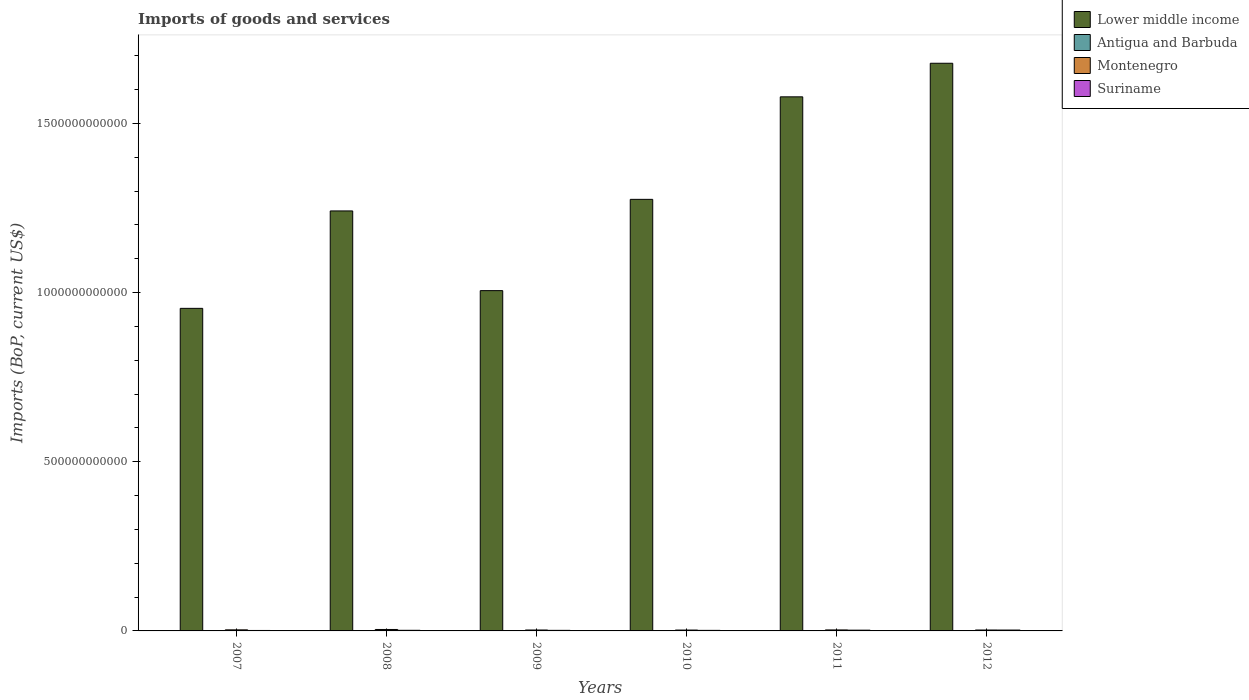How many different coloured bars are there?
Keep it short and to the point. 4. How many groups of bars are there?
Give a very brief answer. 6. Are the number of bars per tick equal to the number of legend labels?
Your answer should be compact. Yes. Are the number of bars on each tick of the X-axis equal?
Your answer should be compact. Yes. What is the amount spent on imports in Lower middle income in 2011?
Ensure brevity in your answer.  1.58e+12. Across all years, what is the maximum amount spent on imports in Lower middle income?
Ensure brevity in your answer.  1.68e+12. Across all years, what is the minimum amount spent on imports in Suriname?
Give a very brief answer. 1.36e+09. In which year was the amount spent on imports in Montenegro minimum?
Your answer should be compact. 2010. What is the total amount spent on imports in Antigua and Barbuda in the graph?
Your response must be concise. 4.60e+09. What is the difference between the amount spent on imports in Suriname in 2009 and that in 2010?
Give a very brief answer. 1.91e+07. What is the difference between the amount spent on imports in Antigua and Barbuda in 2008 and the amount spent on imports in Suriname in 2011?
Your answer should be very brief. -1.29e+09. What is the average amount spent on imports in Suriname per year?
Ensure brevity in your answer.  1.89e+09. In the year 2012, what is the difference between the amount spent on imports in Montenegro and amount spent on imports in Antigua and Barbuda?
Offer a very short reply. 2.04e+09. In how many years, is the amount spent on imports in Suriname greater than 100000000000 US$?
Provide a short and direct response. 0. What is the ratio of the amount spent on imports in Antigua and Barbuda in 2007 to that in 2008?
Your answer should be compact. 0.98. Is the difference between the amount spent on imports in Montenegro in 2007 and 2011 greater than the difference between the amount spent on imports in Antigua and Barbuda in 2007 and 2011?
Your response must be concise. No. What is the difference between the highest and the second highest amount spent on imports in Antigua and Barbuda?
Keep it short and to the point. 1.98e+07. What is the difference between the highest and the lowest amount spent on imports in Suriname?
Your response must be concise. 1.22e+09. In how many years, is the amount spent on imports in Lower middle income greater than the average amount spent on imports in Lower middle income taken over all years?
Keep it short and to the point. 2. Is it the case that in every year, the sum of the amount spent on imports in Suriname and amount spent on imports in Montenegro is greater than the sum of amount spent on imports in Lower middle income and amount spent on imports in Antigua and Barbuda?
Your answer should be very brief. Yes. What does the 1st bar from the left in 2008 represents?
Provide a short and direct response. Lower middle income. What does the 2nd bar from the right in 2008 represents?
Your response must be concise. Montenegro. How many bars are there?
Give a very brief answer. 24. How many years are there in the graph?
Make the answer very short. 6. What is the difference between two consecutive major ticks on the Y-axis?
Offer a terse response. 5.00e+11. Are the values on the major ticks of Y-axis written in scientific E-notation?
Keep it short and to the point. No. Does the graph contain any zero values?
Your response must be concise. No. Where does the legend appear in the graph?
Provide a succinct answer. Top right. What is the title of the graph?
Your answer should be very brief. Imports of goods and services. Does "Lebanon" appear as one of the legend labels in the graph?
Give a very brief answer. No. What is the label or title of the X-axis?
Offer a terse response. Years. What is the label or title of the Y-axis?
Your answer should be compact. Imports (BoP, current US$). What is the Imports (BoP, current US$) in Lower middle income in 2007?
Your answer should be compact. 9.53e+11. What is the Imports (BoP, current US$) in Antigua and Barbuda in 2007?
Offer a terse response. 9.32e+08. What is the Imports (BoP, current US$) of Montenegro in 2007?
Your response must be concise. 3.17e+09. What is the Imports (BoP, current US$) in Suriname in 2007?
Give a very brief answer. 1.36e+09. What is the Imports (BoP, current US$) in Lower middle income in 2008?
Provide a succinct answer. 1.24e+12. What is the Imports (BoP, current US$) of Antigua and Barbuda in 2008?
Your answer should be compact. 9.52e+08. What is the Imports (BoP, current US$) of Montenegro in 2008?
Provide a succinct answer. 4.25e+09. What is the Imports (BoP, current US$) of Suriname in 2008?
Your answer should be compact. 1.81e+09. What is the Imports (BoP, current US$) in Lower middle income in 2009?
Offer a terse response. 1.01e+12. What is the Imports (BoP, current US$) of Antigua and Barbuda in 2009?
Offer a terse response. 7.06e+08. What is the Imports (BoP, current US$) of Montenegro in 2009?
Give a very brief answer. 2.71e+09. What is the Imports (BoP, current US$) in Suriname in 2009?
Offer a very short reply. 1.68e+09. What is the Imports (BoP, current US$) in Lower middle income in 2010?
Your answer should be compact. 1.28e+12. What is the Imports (BoP, current US$) in Antigua and Barbuda in 2010?
Offer a very short reply. 6.79e+08. What is the Imports (BoP, current US$) in Montenegro in 2010?
Keep it short and to the point. 2.58e+09. What is the Imports (BoP, current US$) in Suriname in 2010?
Make the answer very short. 1.66e+09. What is the Imports (BoP, current US$) of Lower middle income in 2011?
Ensure brevity in your answer.  1.58e+12. What is the Imports (BoP, current US$) in Antigua and Barbuda in 2011?
Provide a succinct answer. 6.42e+08. What is the Imports (BoP, current US$) of Montenegro in 2011?
Make the answer very short. 2.92e+09. What is the Imports (BoP, current US$) of Suriname in 2011?
Your answer should be compact. 2.24e+09. What is the Imports (BoP, current US$) in Lower middle income in 2012?
Give a very brief answer. 1.68e+12. What is the Imports (BoP, current US$) in Antigua and Barbuda in 2012?
Your response must be concise. 6.88e+08. What is the Imports (BoP, current US$) of Montenegro in 2012?
Your response must be concise. 2.72e+09. What is the Imports (BoP, current US$) of Suriname in 2012?
Keep it short and to the point. 2.58e+09. Across all years, what is the maximum Imports (BoP, current US$) in Lower middle income?
Ensure brevity in your answer.  1.68e+12. Across all years, what is the maximum Imports (BoP, current US$) in Antigua and Barbuda?
Make the answer very short. 9.52e+08. Across all years, what is the maximum Imports (BoP, current US$) of Montenegro?
Ensure brevity in your answer.  4.25e+09. Across all years, what is the maximum Imports (BoP, current US$) of Suriname?
Your answer should be compact. 2.58e+09. Across all years, what is the minimum Imports (BoP, current US$) of Lower middle income?
Provide a short and direct response. 9.53e+11. Across all years, what is the minimum Imports (BoP, current US$) of Antigua and Barbuda?
Your response must be concise. 6.42e+08. Across all years, what is the minimum Imports (BoP, current US$) of Montenegro?
Ensure brevity in your answer.  2.58e+09. Across all years, what is the minimum Imports (BoP, current US$) of Suriname?
Provide a short and direct response. 1.36e+09. What is the total Imports (BoP, current US$) of Lower middle income in the graph?
Your answer should be compact. 7.73e+12. What is the total Imports (BoP, current US$) of Antigua and Barbuda in the graph?
Provide a succinct answer. 4.60e+09. What is the total Imports (BoP, current US$) in Montenegro in the graph?
Make the answer very short. 1.84e+1. What is the total Imports (BoP, current US$) of Suriname in the graph?
Make the answer very short. 1.13e+1. What is the difference between the Imports (BoP, current US$) in Lower middle income in 2007 and that in 2008?
Offer a very short reply. -2.88e+11. What is the difference between the Imports (BoP, current US$) of Antigua and Barbuda in 2007 and that in 2008?
Offer a terse response. -1.98e+07. What is the difference between the Imports (BoP, current US$) of Montenegro in 2007 and that in 2008?
Keep it short and to the point. -1.08e+09. What is the difference between the Imports (BoP, current US$) of Suriname in 2007 and that in 2008?
Your answer should be very brief. -4.51e+08. What is the difference between the Imports (BoP, current US$) in Lower middle income in 2007 and that in 2009?
Your answer should be compact. -5.24e+1. What is the difference between the Imports (BoP, current US$) of Antigua and Barbuda in 2007 and that in 2009?
Ensure brevity in your answer.  2.26e+08. What is the difference between the Imports (BoP, current US$) of Montenegro in 2007 and that in 2009?
Provide a succinct answer. 4.57e+08. What is the difference between the Imports (BoP, current US$) of Suriname in 2007 and that in 2009?
Provide a succinct answer. -3.13e+08. What is the difference between the Imports (BoP, current US$) in Lower middle income in 2007 and that in 2010?
Offer a terse response. -3.22e+11. What is the difference between the Imports (BoP, current US$) of Antigua and Barbuda in 2007 and that in 2010?
Your answer should be very brief. 2.53e+08. What is the difference between the Imports (BoP, current US$) in Montenegro in 2007 and that in 2010?
Provide a short and direct response. 5.92e+08. What is the difference between the Imports (BoP, current US$) in Suriname in 2007 and that in 2010?
Give a very brief answer. -2.94e+08. What is the difference between the Imports (BoP, current US$) in Lower middle income in 2007 and that in 2011?
Offer a terse response. -6.25e+11. What is the difference between the Imports (BoP, current US$) in Antigua and Barbuda in 2007 and that in 2011?
Offer a very short reply. 2.91e+08. What is the difference between the Imports (BoP, current US$) in Montenegro in 2007 and that in 2011?
Your response must be concise. 2.51e+08. What is the difference between the Imports (BoP, current US$) of Suriname in 2007 and that in 2011?
Your answer should be compact. -8.79e+08. What is the difference between the Imports (BoP, current US$) in Lower middle income in 2007 and that in 2012?
Your answer should be very brief. -7.24e+11. What is the difference between the Imports (BoP, current US$) of Antigua and Barbuda in 2007 and that in 2012?
Your answer should be very brief. 2.45e+08. What is the difference between the Imports (BoP, current US$) of Montenegro in 2007 and that in 2012?
Offer a terse response. 4.48e+08. What is the difference between the Imports (BoP, current US$) in Suriname in 2007 and that in 2012?
Your answer should be compact. -1.22e+09. What is the difference between the Imports (BoP, current US$) in Lower middle income in 2008 and that in 2009?
Offer a very short reply. 2.36e+11. What is the difference between the Imports (BoP, current US$) in Antigua and Barbuda in 2008 and that in 2009?
Keep it short and to the point. 2.46e+08. What is the difference between the Imports (BoP, current US$) of Montenegro in 2008 and that in 2009?
Your answer should be very brief. 1.53e+09. What is the difference between the Imports (BoP, current US$) in Suriname in 2008 and that in 2009?
Give a very brief answer. 1.38e+08. What is the difference between the Imports (BoP, current US$) in Lower middle income in 2008 and that in 2010?
Offer a terse response. -3.43e+1. What is the difference between the Imports (BoP, current US$) in Antigua and Barbuda in 2008 and that in 2010?
Your answer should be compact. 2.73e+08. What is the difference between the Imports (BoP, current US$) of Montenegro in 2008 and that in 2010?
Make the answer very short. 1.67e+09. What is the difference between the Imports (BoP, current US$) of Suriname in 2008 and that in 2010?
Your response must be concise. 1.57e+08. What is the difference between the Imports (BoP, current US$) in Lower middle income in 2008 and that in 2011?
Give a very brief answer. -3.37e+11. What is the difference between the Imports (BoP, current US$) in Antigua and Barbuda in 2008 and that in 2011?
Your response must be concise. 3.11e+08. What is the difference between the Imports (BoP, current US$) of Montenegro in 2008 and that in 2011?
Provide a succinct answer. 1.33e+09. What is the difference between the Imports (BoP, current US$) in Suriname in 2008 and that in 2011?
Provide a short and direct response. -4.28e+08. What is the difference between the Imports (BoP, current US$) of Lower middle income in 2008 and that in 2012?
Your answer should be very brief. -4.36e+11. What is the difference between the Imports (BoP, current US$) in Antigua and Barbuda in 2008 and that in 2012?
Your answer should be very brief. 2.65e+08. What is the difference between the Imports (BoP, current US$) in Montenegro in 2008 and that in 2012?
Your answer should be very brief. 1.53e+09. What is the difference between the Imports (BoP, current US$) in Suriname in 2008 and that in 2012?
Offer a very short reply. -7.70e+08. What is the difference between the Imports (BoP, current US$) of Lower middle income in 2009 and that in 2010?
Provide a short and direct response. -2.70e+11. What is the difference between the Imports (BoP, current US$) of Antigua and Barbuda in 2009 and that in 2010?
Your answer should be very brief. 2.75e+07. What is the difference between the Imports (BoP, current US$) of Montenegro in 2009 and that in 2010?
Offer a terse response. 1.34e+08. What is the difference between the Imports (BoP, current US$) of Suriname in 2009 and that in 2010?
Provide a succinct answer. 1.91e+07. What is the difference between the Imports (BoP, current US$) of Lower middle income in 2009 and that in 2011?
Ensure brevity in your answer.  -5.73e+11. What is the difference between the Imports (BoP, current US$) of Antigua and Barbuda in 2009 and that in 2011?
Provide a short and direct response. 6.48e+07. What is the difference between the Imports (BoP, current US$) in Montenegro in 2009 and that in 2011?
Make the answer very short. -2.06e+08. What is the difference between the Imports (BoP, current US$) of Suriname in 2009 and that in 2011?
Give a very brief answer. -5.66e+08. What is the difference between the Imports (BoP, current US$) of Lower middle income in 2009 and that in 2012?
Your response must be concise. -6.72e+11. What is the difference between the Imports (BoP, current US$) in Antigua and Barbuda in 2009 and that in 2012?
Give a very brief answer. 1.88e+07. What is the difference between the Imports (BoP, current US$) in Montenegro in 2009 and that in 2012?
Provide a short and direct response. -9.23e+06. What is the difference between the Imports (BoP, current US$) of Suriname in 2009 and that in 2012?
Make the answer very short. -9.08e+08. What is the difference between the Imports (BoP, current US$) of Lower middle income in 2010 and that in 2011?
Ensure brevity in your answer.  -3.03e+11. What is the difference between the Imports (BoP, current US$) in Antigua and Barbuda in 2010 and that in 2011?
Keep it short and to the point. 3.73e+07. What is the difference between the Imports (BoP, current US$) in Montenegro in 2010 and that in 2011?
Provide a short and direct response. -3.40e+08. What is the difference between the Imports (BoP, current US$) in Suriname in 2010 and that in 2011?
Your answer should be compact. -5.85e+08. What is the difference between the Imports (BoP, current US$) of Lower middle income in 2010 and that in 2012?
Offer a terse response. -4.02e+11. What is the difference between the Imports (BoP, current US$) of Antigua and Barbuda in 2010 and that in 2012?
Keep it short and to the point. -8.70e+06. What is the difference between the Imports (BoP, current US$) in Montenegro in 2010 and that in 2012?
Your answer should be very brief. -1.44e+08. What is the difference between the Imports (BoP, current US$) in Suriname in 2010 and that in 2012?
Keep it short and to the point. -9.27e+08. What is the difference between the Imports (BoP, current US$) in Lower middle income in 2011 and that in 2012?
Your answer should be very brief. -9.92e+1. What is the difference between the Imports (BoP, current US$) in Antigua and Barbuda in 2011 and that in 2012?
Keep it short and to the point. -4.60e+07. What is the difference between the Imports (BoP, current US$) in Montenegro in 2011 and that in 2012?
Offer a very short reply. 1.96e+08. What is the difference between the Imports (BoP, current US$) of Suriname in 2011 and that in 2012?
Make the answer very short. -3.42e+08. What is the difference between the Imports (BoP, current US$) in Lower middle income in 2007 and the Imports (BoP, current US$) in Antigua and Barbuda in 2008?
Offer a very short reply. 9.52e+11. What is the difference between the Imports (BoP, current US$) of Lower middle income in 2007 and the Imports (BoP, current US$) of Montenegro in 2008?
Provide a succinct answer. 9.49e+11. What is the difference between the Imports (BoP, current US$) of Lower middle income in 2007 and the Imports (BoP, current US$) of Suriname in 2008?
Offer a terse response. 9.52e+11. What is the difference between the Imports (BoP, current US$) in Antigua and Barbuda in 2007 and the Imports (BoP, current US$) in Montenegro in 2008?
Provide a succinct answer. -3.32e+09. What is the difference between the Imports (BoP, current US$) in Antigua and Barbuda in 2007 and the Imports (BoP, current US$) in Suriname in 2008?
Your answer should be very brief. -8.82e+08. What is the difference between the Imports (BoP, current US$) in Montenegro in 2007 and the Imports (BoP, current US$) in Suriname in 2008?
Ensure brevity in your answer.  1.36e+09. What is the difference between the Imports (BoP, current US$) of Lower middle income in 2007 and the Imports (BoP, current US$) of Antigua and Barbuda in 2009?
Give a very brief answer. 9.53e+11. What is the difference between the Imports (BoP, current US$) of Lower middle income in 2007 and the Imports (BoP, current US$) of Montenegro in 2009?
Provide a succinct answer. 9.51e+11. What is the difference between the Imports (BoP, current US$) in Lower middle income in 2007 and the Imports (BoP, current US$) in Suriname in 2009?
Your response must be concise. 9.52e+11. What is the difference between the Imports (BoP, current US$) of Antigua and Barbuda in 2007 and the Imports (BoP, current US$) of Montenegro in 2009?
Ensure brevity in your answer.  -1.78e+09. What is the difference between the Imports (BoP, current US$) of Antigua and Barbuda in 2007 and the Imports (BoP, current US$) of Suriname in 2009?
Your answer should be very brief. -7.44e+08. What is the difference between the Imports (BoP, current US$) of Montenegro in 2007 and the Imports (BoP, current US$) of Suriname in 2009?
Provide a succinct answer. 1.49e+09. What is the difference between the Imports (BoP, current US$) in Lower middle income in 2007 and the Imports (BoP, current US$) in Antigua and Barbuda in 2010?
Offer a very short reply. 9.53e+11. What is the difference between the Imports (BoP, current US$) in Lower middle income in 2007 and the Imports (BoP, current US$) in Montenegro in 2010?
Give a very brief answer. 9.51e+11. What is the difference between the Imports (BoP, current US$) of Lower middle income in 2007 and the Imports (BoP, current US$) of Suriname in 2010?
Give a very brief answer. 9.52e+11. What is the difference between the Imports (BoP, current US$) of Antigua and Barbuda in 2007 and the Imports (BoP, current US$) of Montenegro in 2010?
Your answer should be very brief. -1.65e+09. What is the difference between the Imports (BoP, current US$) of Antigua and Barbuda in 2007 and the Imports (BoP, current US$) of Suriname in 2010?
Offer a very short reply. -7.25e+08. What is the difference between the Imports (BoP, current US$) of Montenegro in 2007 and the Imports (BoP, current US$) of Suriname in 2010?
Provide a short and direct response. 1.51e+09. What is the difference between the Imports (BoP, current US$) of Lower middle income in 2007 and the Imports (BoP, current US$) of Antigua and Barbuda in 2011?
Your answer should be compact. 9.53e+11. What is the difference between the Imports (BoP, current US$) of Lower middle income in 2007 and the Imports (BoP, current US$) of Montenegro in 2011?
Provide a succinct answer. 9.51e+11. What is the difference between the Imports (BoP, current US$) of Lower middle income in 2007 and the Imports (BoP, current US$) of Suriname in 2011?
Your answer should be very brief. 9.51e+11. What is the difference between the Imports (BoP, current US$) in Antigua and Barbuda in 2007 and the Imports (BoP, current US$) in Montenegro in 2011?
Ensure brevity in your answer.  -1.99e+09. What is the difference between the Imports (BoP, current US$) in Antigua and Barbuda in 2007 and the Imports (BoP, current US$) in Suriname in 2011?
Offer a terse response. -1.31e+09. What is the difference between the Imports (BoP, current US$) of Montenegro in 2007 and the Imports (BoP, current US$) of Suriname in 2011?
Offer a very short reply. 9.29e+08. What is the difference between the Imports (BoP, current US$) in Lower middle income in 2007 and the Imports (BoP, current US$) in Antigua and Barbuda in 2012?
Your response must be concise. 9.53e+11. What is the difference between the Imports (BoP, current US$) of Lower middle income in 2007 and the Imports (BoP, current US$) of Montenegro in 2012?
Provide a succinct answer. 9.51e+11. What is the difference between the Imports (BoP, current US$) in Lower middle income in 2007 and the Imports (BoP, current US$) in Suriname in 2012?
Give a very brief answer. 9.51e+11. What is the difference between the Imports (BoP, current US$) in Antigua and Barbuda in 2007 and the Imports (BoP, current US$) in Montenegro in 2012?
Your answer should be compact. -1.79e+09. What is the difference between the Imports (BoP, current US$) of Antigua and Barbuda in 2007 and the Imports (BoP, current US$) of Suriname in 2012?
Provide a short and direct response. -1.65e+09. What is the difference between the Imports (BoP, current US$) in Montenegro in 2007 and the Imports (BoP, current US$) in Suriname in 2012?
Provide a short and direct response. 5.87e+08. What is the difference between the Imports (BoP, current US$) in Lower middle income in 2008 and the Imports (BoP, current US$) in Antigua and Barbuda in 2009?
Provide a succinct answer. 1.24e+12. What is the difference between the Imports (BoP, current US$) of Lower middle income in 2008 and the Imports (BoP, current US$) of Montenegro in 2009?
Your response must be concise. 1.24e+12. What is the difference between the Imports (BoP, current US$) in Lower middle income in 2008 and the Imports (BoP, current US$) in Suriname in 2009?
Ensure brevity in your answer.  1.24e+12. What is the difference between the Imports (BoP, current US$) in Antigua and Barbuda in 2008 and the Imports (BoP, current US$) in Montenegro in 2009?
Ensure brevity in your answer.  -1.76e+09. What is the difference between the Imports (BoP, current US$) in Antigua and Barbuda in 2008 and the Imports (BoP, current US$) in Suriname in 2009?
Your answer should be compact. -7.24e+08. What is the difference between the Imports (BoP, current US$) of Montenegro in 2008 and the Imports (BoP, current US$) of Suriname in 2009?
Your answer should be compact. 2.57e+09. What is the difference between the Imports (BoP, current US$) of Lower middle income in 2008 and the Imports (BoP, current US$) of Antigua and Barbuda in 2010?
Keep it short and to the point. 1.24e+12. What is the difference between the Imports (BoP, current US$) of Lower middle income in 2008 and the Imports (BoP, current US$) of Montenegro in 2010?
Ensure brevity in your answer.  1.24e+12. What is the difference between the Imports (BoP, current US$) of Lower middle income in 2008 and the Imports (BoP, current US$) of Suriname in 2010?
Ensure brevity in your answer.  1.24e+12. What is the difference between the Imports (BoP, current US$) in Antigua and Barbuda in 2008 and the Imports (BoP, current US$) in Montenegro in 2010?
Your response must be concise. -1.63e+09. What is the difference between the Imports (BoP, current US$) of Antigua and Barbuda in 2008 and the Imports (BoP, current US$) of Suriname in 2010?
Your response must be concise. -7.05e+08. What is the difference between the Imports (BoP, current US$) in Montenegro in 2008 and the Imports (BoP, current US$) in Suriname in 2010?
Your response must be concise. 2.59e+09. What is the difference between the Imports (BoP, current US$) of Lower middle income in 2008 and the Imports (BoP, current US$) of Antigua and Barbuda in 2011?
Give a very brief answer. 1.24e+12. What is the difference between the Imports (BoP, current US$) in Lower middle income in 2008 and the Imports (BoP, current US$) in Montenegro in 2011?
Your answer should be very brief. 1.24e+12. What is the difference between the Imports (BoP, current US$) in Lower middle income in 2008 and the Imports (BoP, current US$) in Suriname in 2011?
Your answer should be compact. 1.24e+12. What is the difference between the Imports (BoP, current US$) of Antigua and Barbuda in 2008 and the Imports (BoP, current US$) of Montenegro in 2011?
Provide a succinct answer. -1.97e+09. What is the difference between the Imports (BoP, current US$) in Antigua and Barbuda in 2008 and the Imports (BoP, current US$) in Suriname in 2011?
Offer a terse response. -1.29e+09. What is the difference between the Imports (BoP, current US$) of Montenegro in 2008 and the Imports (BoP, current US$) of Suriname in 2011?
Your answer should be compact. 2.01e+09. What is the difference between the Imports (BoP, current US$) in Lower middle income in 2008 and the Imports (BoP, current US$) in Antigua and Barbuda in 2012?
Provide a short and direct response. 1.24e+12. What is the difference between the Imports (BoP, current US$) in Lower middle income in 2008 and the Imports (BoP, current US$) in Montenegro in 2012?
Keep it short and to the point. 1.24e+12. What is the difference between the Imports (BoP, current US$) of Lower middle income in 2008 and the Imports (BoP, current US$) of Suriname in 2012?
Provide a succinct answer. 1.24e+12. What is the difference between the Imports (BoP, current US$) in Antigua and Barbuda in 2008 and the Imports (BoP, current US$) in Montenegro in 2012?
Offer a terse response. -1.77e+09. What is the difference between the Imports (BoP, current US$) of Antigua and Barbuda in 2008 and the Imports (BoP, current US$) of Suriname in 2012?
Provide a succinct answer. -1.63e+09. What is the difference between the Imports (BoP, current US$) in Montenegro in 2008 and the Imports (BoP, current US$) in Suriname in 2012?
Your answer should be very brief. 1.66e+09. What is the difference between the Imports (BoP, current US$) in Lower middle income in 2009 and the Imports (BoP, current US$) in Antigua and Barbuda in 2010?
Your answer should be compact. 1.01e+12. What is the difference between the Imports (BoP, current US$) in Lower middle income in 2009 and the Imports (BoP, current US$) in Montenegro in 2010?
Give a very brief answer. 1.00e+12. What is the difference between the Imports (BoP, current US$) in Lower middle income in 2009 and the Imports (BoP, current US$) in Suriname in 2010?
Keep it short and to the point. 1.00e+12. What is the difference between the Imports (BoP, current US$) in Antigua and Barbuda in 2009 and the Imports (BoP, current US$) in Montenegro in 2010?
Keep it short and to the point. -1.87e+09. What is the difference between the Imports (BoP, current US$) of Antigua and Barbuda in 2009 and the Imports (BoP, current US$) of Suriname in 2010?
Your answer should be compact. -9.50e+08. What is the difference between the Imports (BoP, current US$) in Montenegro in 2009 and the Imports (BoP, current US$) in Suriname in 2010?
Ensure brevity in your answer.  1.06e+09. What is the difference between the Imports (BoP, current US$) of Lower middle income in 2009 and the Imports (BoP, current US$) of Antigua and Barbuda in 2011?
Make the answer very short. 1.01e+12. What is the difference between the Imports (BoP, current US$) of Lower middle income in 2009 and the Imports (BoP, current US$) of Montenegro in 2011?
Make the answer very short. 1.00e+12. What is the difference between the Imports (BoP, current US$) of Lower middle income in 2009 and the Imports (BoP, current US$) of Suriname in 2011?
Your response must be concise. 1.00e+12. What is the difference between the Imports (BoP, current US$) of Antigua and Barbuda in 2009 and the Imports (BoP, current US$) of Montenegro in 2011?
Your response must be concise. -2.21e+09. What is the difference between the Imports (BoP, current US$) of Antigua and Barbuda in 2009 and the Imports (BoP, current US$) of Suriname in 2011?
Offer a terse response. -1.54e+09. What is the difference between the Imports (BoP, current US$) of Montenegro in 2009 and the Imports (BoP, current US$) of Suriname in 2011?
Provide a succinct answer. 4.72e+08. What is the difference between the Imports (BoP, current US$) in Lower middle income in 2009 and the Imports (BoP, current US$) in Antigua and Barbuda in 2012?
Your response must be concise. 1.01e+12. What is the difference between the Imports (BoP, current US$) in Lower middle income in 2009 and the Imports (BoP, current US$) in Montenegro in 2012?
Provide a short and direct response. 1.00e+12. What is the difference between the Imports (BoP, current US$) of Lower middle income in 2009 and the Imports (BoP, current US$) of Suriname in 2012?
Provide a short and direct response. 1.00e+12. What is the difference between the Imports (BoP, current US$) of Antigua and Barbuda in 2009 and the Imports (BoP, current US$) of Montenegro in 2012?
Give a very brief answer. -2.02e+09. What is the difference between the Imports (BoP, current US$) of Antigua and Barbuda in 2009 and the Imports (BoP, current US$) of Suriname in 2012?
Your answer should be compact. -1.88e+09. What is the difference between the Imports (BoP, current US$) in Montenegro in 2009 and the Imports (BoP, current US$) in Suriname in 2012?
Provide a short and direct response. 1.30e+08. What is the difference between the Imports (BoP, current US$) in Lower middle income in 2010 and the Imports (BoP, current US$) in Antigua and Barbuda in 2011?
Make the answer very short. 1.27e+12. What is the difference between the Imports (BoP, current US$) of Lower middle income in 2010 and the Imports (BoP, current US$) of Montenegro in 2011?
Make the answer very short. 1.27e+12. What is the difference between the Imports (BoP, current US$) in Lower middle income in 2010 and the Imports (BoP, current US$) in Suriname in 2011?
Your answer should be compact. 1.27e+12. What is the difference between the Imports (BoP, current US$) of Antigua and Barbuda in 2010 and the Imports (BoP, current US$) of Montenegro in 2011?
Your answer should be very brief. -2.24e+09. What is the difference between the Imports (BoP, current US$) of Antigua and Barbuda in 2010 and the Imports (BoP, current US$) of Suriname in 2011?
Ensure brevity in your answer.  -1.56e+09. What is the difference between the Imports (BoP, current US$) of Montenegro in 2010 and the Imports (BoP, current US$) of Suriname in 2011?
Keep it short and to the point. 3.38e+08. What is the difference between the Imports (BoP, current US$) in Lower middle income in 2010 and the Imports (BoP, current US$) in Antigua and Barbuda in 2012?
Your response must be concise. 1.27e+12. What is the difference between the Imports (BoP, current US$) in Lower middle income in 2010 and the Imports (BoP, current US$) in Montenegro in 2012?
Your response must be concise. 1.27e+12. What is the difference between the Imports (BoP, current US$) of Lower middle income in 2010 and the Imports (BoP, current US$) of Suriname in 2012?
Your answer should be compact. 1.27e+12. What is the difference between the Imports (BoP, current US$) in Antigua and Barbuda in 2010 and the Imports (BoP, current US$) in Montenegro in 2012?
Ensure brevity in your answer.  -2.04e+09. What is the difference between the Imports (BoP, current US$) of Antigua and Barbuda in 2010 and the Imports (BoP, current US$) of Suriname in 2012?
Your answer should be very brief. -1.90e+09. What is the difference between the Imports (BoP, current US$) of Montenegro in 2010 and the Imports (BoP, current US$) of Suriname in 2012?
Offer a terse response. -4.80e+06. What is the difference between the Imports (BoP, current US$) in Lower middle income in 2011 and the Imports (BoP, current US$) in Antigua and Barbuda in 2012?
Provide a succinct answer. 1.58e+12. What is the difference between the Imports (BoP, current US$) of Lower middle income in 2011 and the Imports (BoP, current US$) of Montenegro in 2012?
Make the answer very short. 1.58e+12. What is the difference between the Imports (BoP, current US$) of Lower middle income in 2011 and the Imports (BoP, current US$) of Suriname in 2012?
Offer a very short reply. 1.58e+12. What is the difference between the Imports (BoP, current US$) of Antigua and Barbuda in 2011 and the Imports (BoP, current US$) of Montenegro in 2012?
Give a very brief answer. -2.08e+09. What is the difference between the Imports (BoP, current US$) in Antigua and Barbuda in 2011 and the Imports (BoP, current US$) in Suriname in 2012?
Make the answer very short. -1.94e+09. What is the difference between the Imports (BoP, current US$) in Montenegro in 2011 and the Imports (BoP, current US$) in Suriname in 2012?
Give a very brief answer. 3.35e+08. What is the average Imports (BoP, current US$) of Lower middle income per year?
Make the answer very short. 1.29e+12. What is the average Imports (BoP, current US$) in Antigua and Barbuda per year?
Ensure brevity in your answer.  7.67e+08. What is the average Imports (BoP, current US$) of Montenegro per year?
Offer a very short reply. 3.06e+09. What is the average Imports (BoP, current US$) in Suriname per year?
Offer a terse response. 1.89e+09. In the year 2007, what is the difference between the Imports (BoP, current US$) of Lower middle income and Imports (BoP, current US$) of Antigua and Barbuda?
Your answer should be compact. 9.52e+11. In the year 2007, what is the difference between the Imports (BoP, current US$) in Lower middle income and Imports (BoP, current US$) in Montenegro?
Ensure brevity in your answer.  9.50e+11. In the year 2007, what is the difference between the Imports (BoP, current US$) in Lower middle income and Imports (BoP, current US$) in Suriname?
Ensure brevity in your answer.  9.52e+11. In the year 2007, what is the difference between the Imports (BoP, current US$) in Antigua and Barbuda and Imports (BoP, current US$) in Montenegro?
Your answer should be very brief. -2.24e+09. In the year 2007, what is the difference between the Imports (BoP, current US$) of Antigua and Barbuda and Imports (BoP, current US$) of Suriname?
Provide a succinct answer. -4.30e+08. In the year 2007, what is the difference between the Imports (BoP, current US$) in Montenegro and Imports (BoP, current US$) in Suriname?
Offer a very short reply. 1.81e+09. In the year 2008, what is the difference between the Imports (BoP, current US$) of Lower middle income and Imports (BoP, current US$) of Antigua and Barbuda?
Your answer should be compact. 1.24e+12. In the year 2008, what is the difference between the Imports (BoP, current US$) in Lower middle income and Imports (BoP, current US$) in Montenegro?
Your answer should be very brief. 1.24e+12. In the year 2008, what is the difference between the Imports (BoP, current US$) of Lower middle income and Imports (BoP, current US$) of Suriname?
Your response must be concise. 1.24e+12. In the year 2008, what is the difference between the Imports (BoP, current US$) of Antigua and Barbuda and Imports (BoP, current US$) of Montenegro?
Keep it short and to the point. -3.30e+09. In the year 2008, what is the difference between the Imports (BoP, current US$) in Antigua and Barbuda and Imports (BoP, current US$) in Suriname?
Offer a very short reply. -8.62e+08. In the year 2008, what is the difference between the Imports (BoP, current US$) of Montenegro and Imports (BoP, current US$) of Suriname?
Your response must be concise. 2.43e+09. In the year 2009, what is the difference between the Imports (BoP, current US$) in Lower middle income and Imports (BoP, current US$) in Antigua and Barbuda?
Your response must be concise. 1.01e+12. In the year 2009, what is the difference between the Imports (BoP, current US$) of Lower middle income and Imports (BoP, current US$) of Montenegro?
Offer a terse response. 1.00e+12. In the year 2009, what is the difference between the Imports (BoP, current US$) in Lower middle income and Imports (BoP, current US$) in Suriname?
Make the answer very short. 1.00e+12. In the year 2009, what is the difference between the Imports (BoP, current US$) in Antigua and Barbuda and Imports (BoP, current US$) in Montenegro?
Your response must be concise. -2.01e+09. In the year 2009, what is the difference between the Imports (BoP, current US$) in Antigua and Barbuda and Imports (BoP, current US$) in Suriname?
Offer a very short reply. -9.70e+08. In the year 2009, what is the difference between the Imports (BoP, current US$) in Montenegro and Imports (BoP, current US$) in Suriname?
Give a very brief answer. 1.04e+09. In the year 2010, what is the difference between the Imports (BoP, current US$) of Lower middle income and Imports (BoP, current US$) of Antigua and Barbuda?
Your answer should be very brief. 1.27e+12. In the year 2010, what is the difference between the Imports (BoP, current US$) in Lower middle income and Imports (BoP, current US$) in Montenegro?
Offer a terse response. 1.27e+12. In the year 2010, what is the difference between the Imports (BoP, current US$) in Lower middle income and Imports (BoP, current US$) in Suriname?
Provide a short and direct response. 1.27e+12. In the year 2010, what is the difference between the Imports (BoP, current US$) of Antigua and Barbuda and Imports (BoP, current US$) of Montenegro?
Your response must be concise. -1.90e+09. In the year 2010, what is the difference between the Imports (BoP, current US$) of Antigua and Barbuda and Imports (BoP, current US$) of Suriname?
Give a very brief answer. -9.78e+08. In the year 2010, what is the difference between the Imports (BoP, current US$) in Montenegro and Imports (BoP, current US$) in Suriname?
Your answer should be very brief. 9.22e+08. In the year 2011, what is the difference between the Imports (BoP, current US$) in Lower middle income and Imports (BoP, current US$) in Antigua and Barbuda?
Offer a very short reply. 1.58e+12. In the year 2011, what is the difference between the Imports (BoP, current US$) in Lower middle income and Imports (BoP, current US$) in Montenegro?
Offer a terse response. 1.58e+12. In the year 2011, what is the difference between the Imports (BoP, current US$) in Lower middle income and Imports (BoP, current US$) in Suriname?
Your answer should be very brief. 1.58e+12. In the year 2011, what is the difference between the Imports (BoP, current US$) of Antigua and Barbuda and Imports (BoP, current US$) of Montenegro?
Make the answer very short. -2.28e+09. In the year 2011, what is the difference between the Imports (BoP, current US$) of Antigua and Barbuda and Imports (BoP, current US$) of Suriname?
Ensure brevity in your answer.  -1.60e+09. In the year 2011, what is the difference between the Imports (BoP, current US$) of Montenegro and Imports (BoP, current US$) of Suriname?
Offer a very short reply. 6.78e+08. In the year 2012, what is the difference between the Imports (BoP, current US$) of Lower middle income and Imports (BoP, current US$) of Antigua and Barbuda?
Ensure brevity in your answer.  1.68e+12. In the year 2012, what is the difference between the Imports (BoP, current US$) of Lower middle income and Imports (BoP, current US$) of Montenegro?
Give a very brief answer. 1.68e+12. In the year 2012, what is the difference between the Imports (BoP, current US$) in Lower middle income and Imports (BoP, current US$) in Suriname?
Your response must be concise. 1.68e+12. In the year 2012, what is the difference between the Imports (BoP, current US$) in Antigua and Barbuda and Imports (BoP, current US$) in Montenegro?
Ensure brevity in your answer.  -2.04e+09. In the year 2012, what is the difference between the Imports (BoP, current US$) of Antigua and Barbuda and Imports (BoP, current US$) of Suriname?
Give a very brief answer. -1.90e+09. In the year 2012, what is the difference between the Imports (BoP, current US$) of Montenegro and Imports (BoP, current US$) of Suriname?
Your answer should be compact. 1.39e+08. What is the ratio of the Imports (BoP, current US$) in Lower middle income in 2007 to that in 2008?
Provide a short and direct response. 0.77. What is the ratio of the Imports (BoP, current US$) of Antigua and Barbuda in 2007 to that in 2008?
Your answer should be compact. 0.98. What is the ratio of the Imports (BoP, current US$) in Montenegro in 2007 to that in 2008?
Provide a short and direct response. 0.75. What is the ratio of the Imports (BoP, current US$) in Suriname in 2007 to that in 2008?
Provide a short and direct response. 0.75. What is the ratio of the Imports (BoP, current US$) in Lower middle income in 2007 to that in 2009?
Offer a terse response. 0.95. What is the ratio of the Imports (BoP, current US$) in Antigua and Barbuda in 2007 to that in 2009?
Keep it short and to the point. 1.32. What is the ratio of the Imports (BoP, current US$) in Montenegro in 2007 to that in 2009?
Your answer should be very brief. 1.17. What is the ratio of the Imports (BoP, current US$) in Suriname in 2007 to that in 2009?
Provide a short and direct response. 0.81. What is the ratio of the Imports (BoP, current US$) in Lower middle income in 2007 to that in 2010?
Provide a short and direct response. 0.75. What is the ratio of the Imports (BoP, current US$) of Antigua and Barbuda in 2007 to that in 2010?
Your response must be concise. 1.37. What is the ratio of the Imports (BoP, current US$) in Montenegro in 2007 to that in 2010?
Keep it short and to the point. 1.23. What is the ratio of the Imports (BoP, current US$) of Suriname in 2007 to that in 2010?
Your answer should be compact. 0.82. What is the ratio of the Imports (BoP, current US$) in Lower middle income in 2007 to that in 2011?
Your answer should be compact. 0.6. What is the ratio of the Imports (BoP, current US$) in Antigua and Barbuda in 2007 to that in 2011?
Ensure brevity in your answer.  1.45. What is the ratio of the Imports (BoP, current US$) of Montenegro in 2007 to that in 2011?
Make the answer very short. 1.09. What is the ratio of the Imports (BoP, current US$) of Suriname in 2007 to that in 2011?
Ensure brevity in your answer.  0.61. What is the ratio of the Imports (BoP, current US$) of Lower middle income in 2007 to that in 2012?
Your response must be concise. 0.57. What is the ratio of the Imports (BoP, current US$) of Antigua and Barbuda in 2007 to that in 2012?
Make the answer very short. 1.36. What is the ratio of the Imports (BoP, current US$) of Montenegro in 2007 to that in 2012?
Your answer should be very brief. 1.16. What is the ratio of the Imports (BoP, current US$) of Suriname in 2007 to that in 2012?
Offer a terse response. 0.53. What is the ratio of the Imports (BoP, current US$) of Lower middle income in 2008 to that in 2009?
Offer a terse response. 1.23. What is the ratio of the Imports (BoP, current US$) of Antigua and Barbuda in 2008 to that in 2009?
Keep it short and to the point. 1.35. What is the ratio of the Imports (BoP, current US$) of Montenegro in 2008 to that in 2009?
Your response must be concise. 1.57. What is the ratio of the Imports (BoP, current US$) in Suriname in 2008 to that in 2009?
Provide a short and direct response. 1.08. What is the ratio of the Imports (BoP, current US$) in Lower middle income in 2008 to that in 2010?
Your answer should be compact. 0.97. What is the ratio of the Imports (BoP, current US$) of Antigua and Barbuda in 2008 to that in 2010?
Your answer should be compact. 1.4. What is the ratio of the Imports (BoP, current US$) in Montenegro in 2008 to that in 2010?
Your response must be concise. 1.65. What is the ratio of the Imports (BoP, current US$) in Suriname in 2008 to that in 2010?
Offer a very short reply. 1.09. What is the ratio of the Imports (BoP, current US$) in Lower middle income in 2008 to that in 2011?
Offer a terse response. 0.79. What is the ratio of the Imports (BoP, current US$) of Antigua and Barbuda in 2008 to that in 2011?
Offer a very short reply. 1.48. What is the ratio of the Imports (BoP, current US$) in Montenegro in 2008 to that in 2011?
Provide a short and direct response. 1.46. What is the ratio of the Imports (BoP, current US$) of Suriname in 2008 to that in 2011?
Make the answer very short. 0.81. What is the ratio of the Imports (BoP, current US$) of Lower middle income in 2008 to that in 2012?
Provide a succinct answer. 0.74. What is the ratio of the Imports (BoP, current US$) in Antigua and Barbuda in 2008 to that in 2012?
Give a very brief answer. 1.38. What is the ratio of the Imports (BoP, current US$) of Montenegro in 2008 to that in 2012?
Give a very brief answer. 1.56. What is the ratio of the Imports (BoP, current US$) in Suriname in 2008 to that in 2012?
Ensure brevity in your answer.  0.7. What is the ratio of the Imports (BoP, current US$) of Lower middle income in 2009 to that in 2010?
Provide a short and direct response. 0.79. What is the ratio of the Imports (BoP, current US$) in Antigua and Barbuda in 2009 to that in 2010?
Give a very brief answer. 1.04. What is the ratio of the Imports (BoP, current US$) in Montenegro in 2009 to that in 2010?
Offer a terse response. 1.05. What is the ratio of the Imports (BoP, current US$) in Suriname in 2009 to that in 2010?
Keep it short and to the point. 1.01. What is the ratio of the Imports (BoP, current US$) of Lower middle income in 2009 to that in 2011?
Ensure brevity in your answer.  0.64. What is the ratio of the Imports (BoP, current US$) of Antigua and Barbuda in 2009 to that in 2011?
Keep it short and to the point. 1.1. What is the ratio of the Imports (BoP, current US$) in Montenegro in 2009 to that in 2011?
Provide a short and direct response. 0.93. What is the ratio of the Imports (BoP, current US$) in Suriname in 2009 to that in 2011?
Give a very brief answer. 0.75. What is the ratio of the Imports (BoP, current US$) in Lower middle income in 2009 to that in 2012?
Your response must be concise. 0.6. What is the ratio of the Imports (BoP, current US$) in Antigua and Barbuda in 2009 to that in 2012?
Your response must be concise. 1.03. What is the ratio of the Imports (BoP, current US$) in Montenegro in 2009 to that in 2012?
Give a very brief answer. 1. What is the ratio of the Imports (BoP, current US$) in Suriname in 2009 to that in 2012?
Your answer should be compact. 0.65. What is the ratio of the Imports (BoP, current US$) in Lower middle income in 2010 to that in 2011?
Keep it short and to the point. 0.81. What is the ratio of the Imports (BoP, current US$) in Antigua and Barbuda in 2010 to that in 2011?
Ensure brevity in your answer.  1.06. What is the ratio of the Imports (BoP, current US$) in Montenegro in 2010 to that in 2011?
Provide a succinct answer. 0.88. What is the ratio of the Imports (BoP, current US$) in Suriname in 2010 to that in 2011?
Give a very brief answer. 0.74. What is the ratio of the Imports (BoP, current US$) of Lower middle income in 2010 to that in 2012?
Offer a terse response. 0.76. What is the ratio of the Imports (BoP, current US$) in Antigua and Barbuda in 2010 to that in 2012?
Your response must be concise. 0.99. What is the ratio of the Imports (BoP, current US$) in Montenegro in 2010 to that in 2012?
Give a very brief answer. 0.95. What is the ratio of the Imports (BoP, current US$) in Suriname in 2010 to that in 2012?
Keep it short and to the point. 0.64. What is the ratio of the Imports (BoP, current US$) of Lower middle income in 2011 to that in 2012?
Offer a very short reply. 0.94. What is the ratio of the Imports (BoP, current US$) of Antigua and Barbuda in 2011 to that in 2012?
Make the answer very short. 0.93. What is the ratio of the Imports (BoP, current US$) in Montenegro in 2011 to that in 2012?
Offer a terse response. 1.07. What is the ratio of the Imports (BoP, current US$) of Suriname in 2011 to that in 2012?
Provide a short and direct response. 0.87. What is the difference between the highest and the second highest Imports (BoP, current US$) in Lower middle income?
Offer a very short reply. 9.92e+1. What is the difference between the highest and the second highest Imports (BoP, current US$) of Antigua and Barbuda?
Give a very brief answer. 1.98e+07. What is the difference between the highest and the second highest Imports (BoP, current US$) in Montenegro?
Your response must be concise. 1.08e+09. What is the difference between the highest and the second highest Imports (BoP, current US$) of Suriname?
Your answer should be very brief. 3.42e+08. What is the difference between the highest and the lowest Imports (BoP, current US$) of Lower middle income?
Your answer should be very brief. 7.24e+11. What is the difference between the highest and the lowest Imports (BoP, current US$) in Antigua and Barbuda?
Give a very brief answer. 3.11e+08. What is the difference between the highest and the lowest Imports (BoP, current US$) of Montenegro?
Provide a short and direct response. 1.67e+09. What is the difference between the highest and the lowest Imports (BoP, current US$) in Suriname?
Your answer should be very brief. 1.22e+09. 